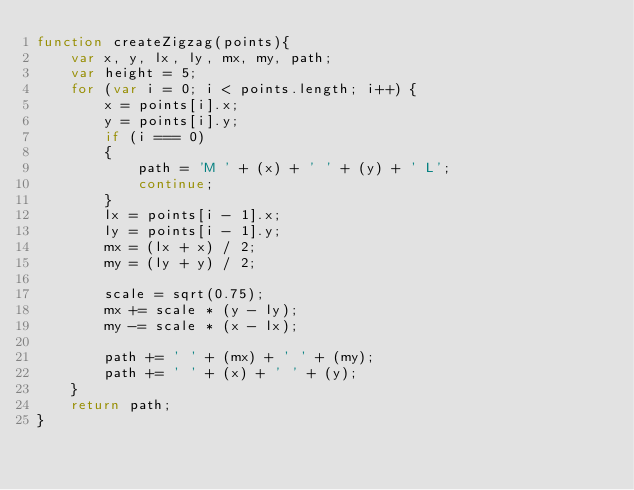<code> <loc_0><loc_0><loc_500><loc_500><_JavaScript_>function createZigzag(points){
    var x, y, lx, ly, mx, my, path;
    var height = 5;
    for (var i = 0; i < points.length; i++) {
        x = points[i].x;
        y = points[i].y;
        if (i === 0)
        {
            path = 'M ' + (x) + ' ' + (y) + ' L';
            continue;
        }
        lx = points[i - 1].x;
        ly = points[i - 1].y;
        mx = (lx + x) / 2;
        my = (ly + y) / 2;

        scale = sqrt(0.75);
        mx += scale * (y - ly);
        my -= scale * (x - lx);

        path += ' ' + (mx) + ' ' + (my);
        path += ' ' + (x) + ' ' + (y);
    }
    return path;
}
</code> 